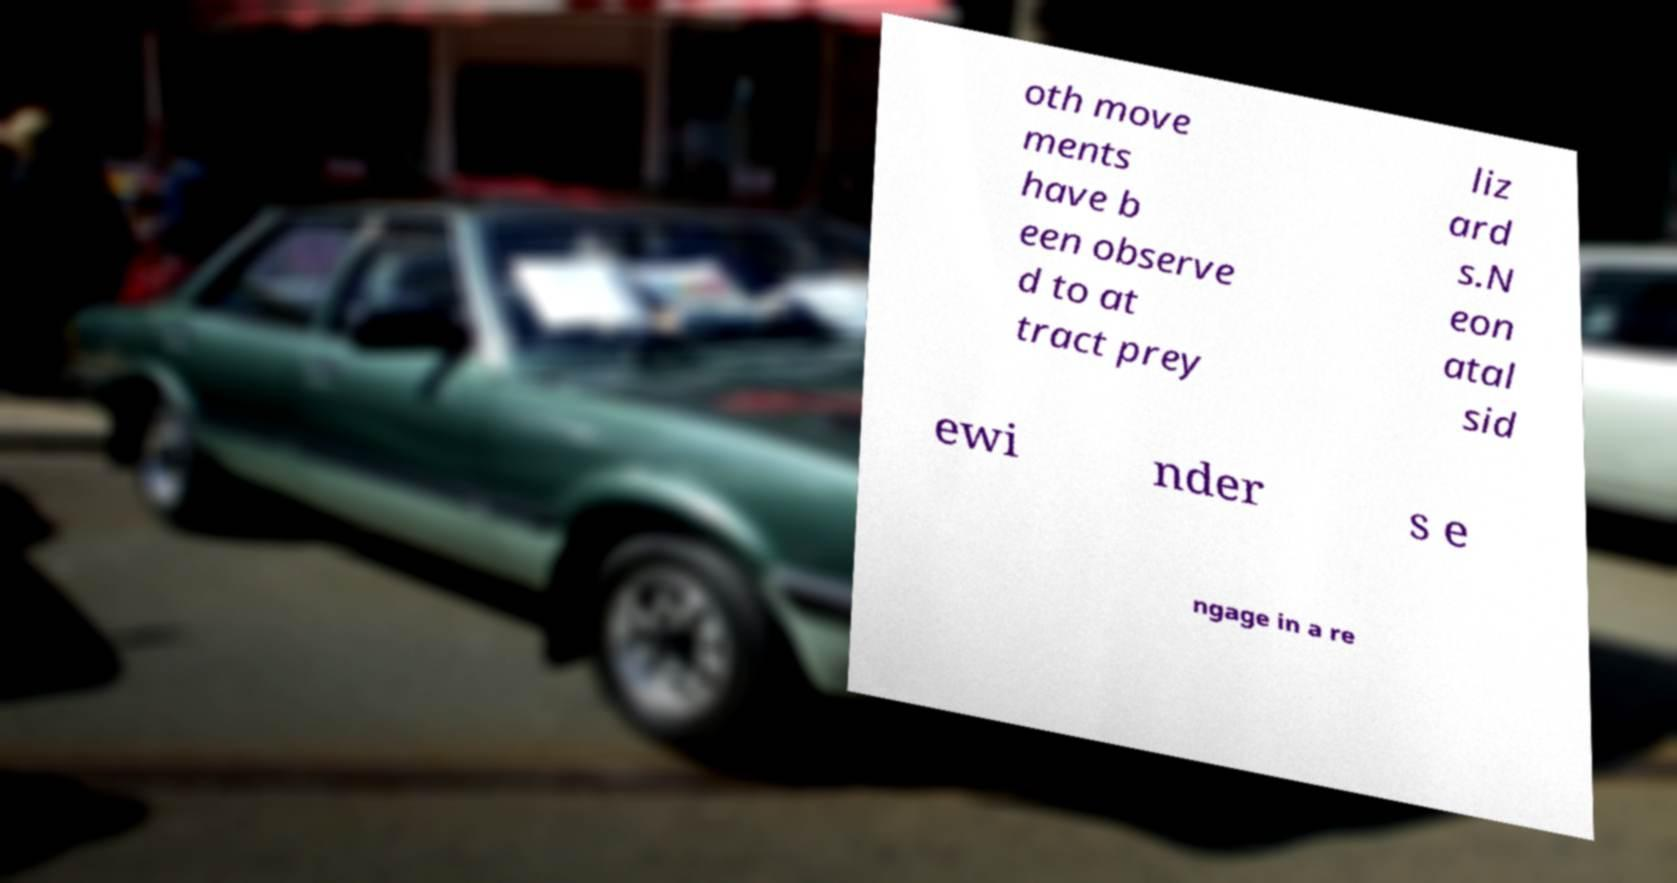Please identify and transcribe the text found in this image. oth move ments have b een observe d to at tract prey liz ard s.N eon atal sid ewi nder s e ngage in a re 